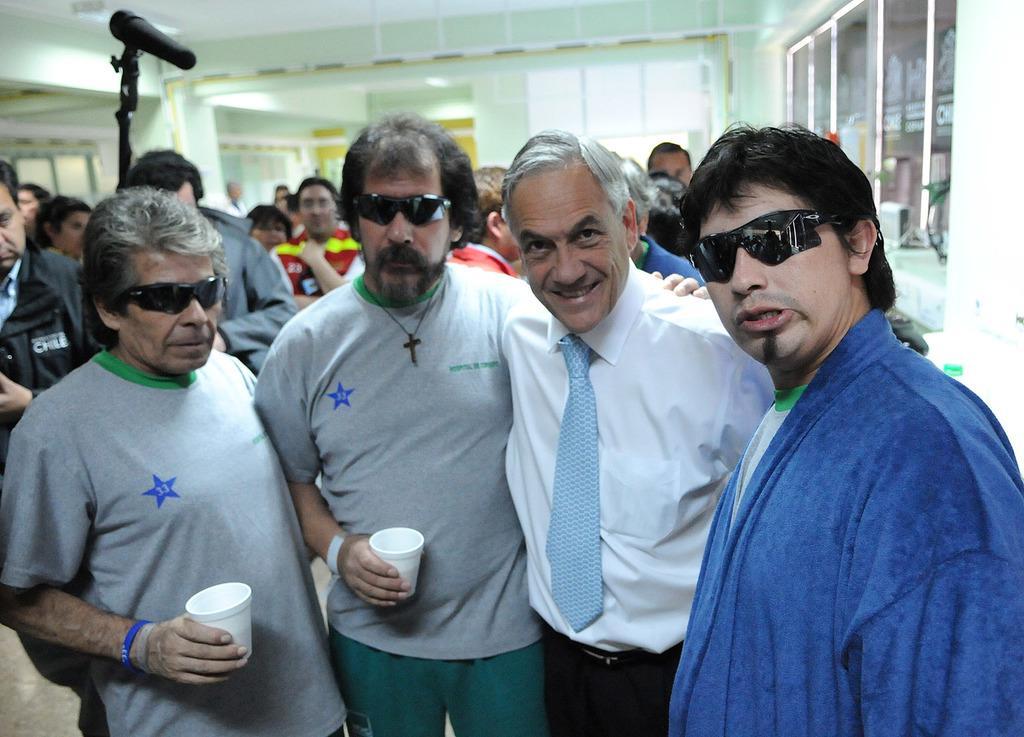Describe this image in one or two sentences. There are four people standing and these two people are holding cups. Background we can see people,microphone with stand and glass. 